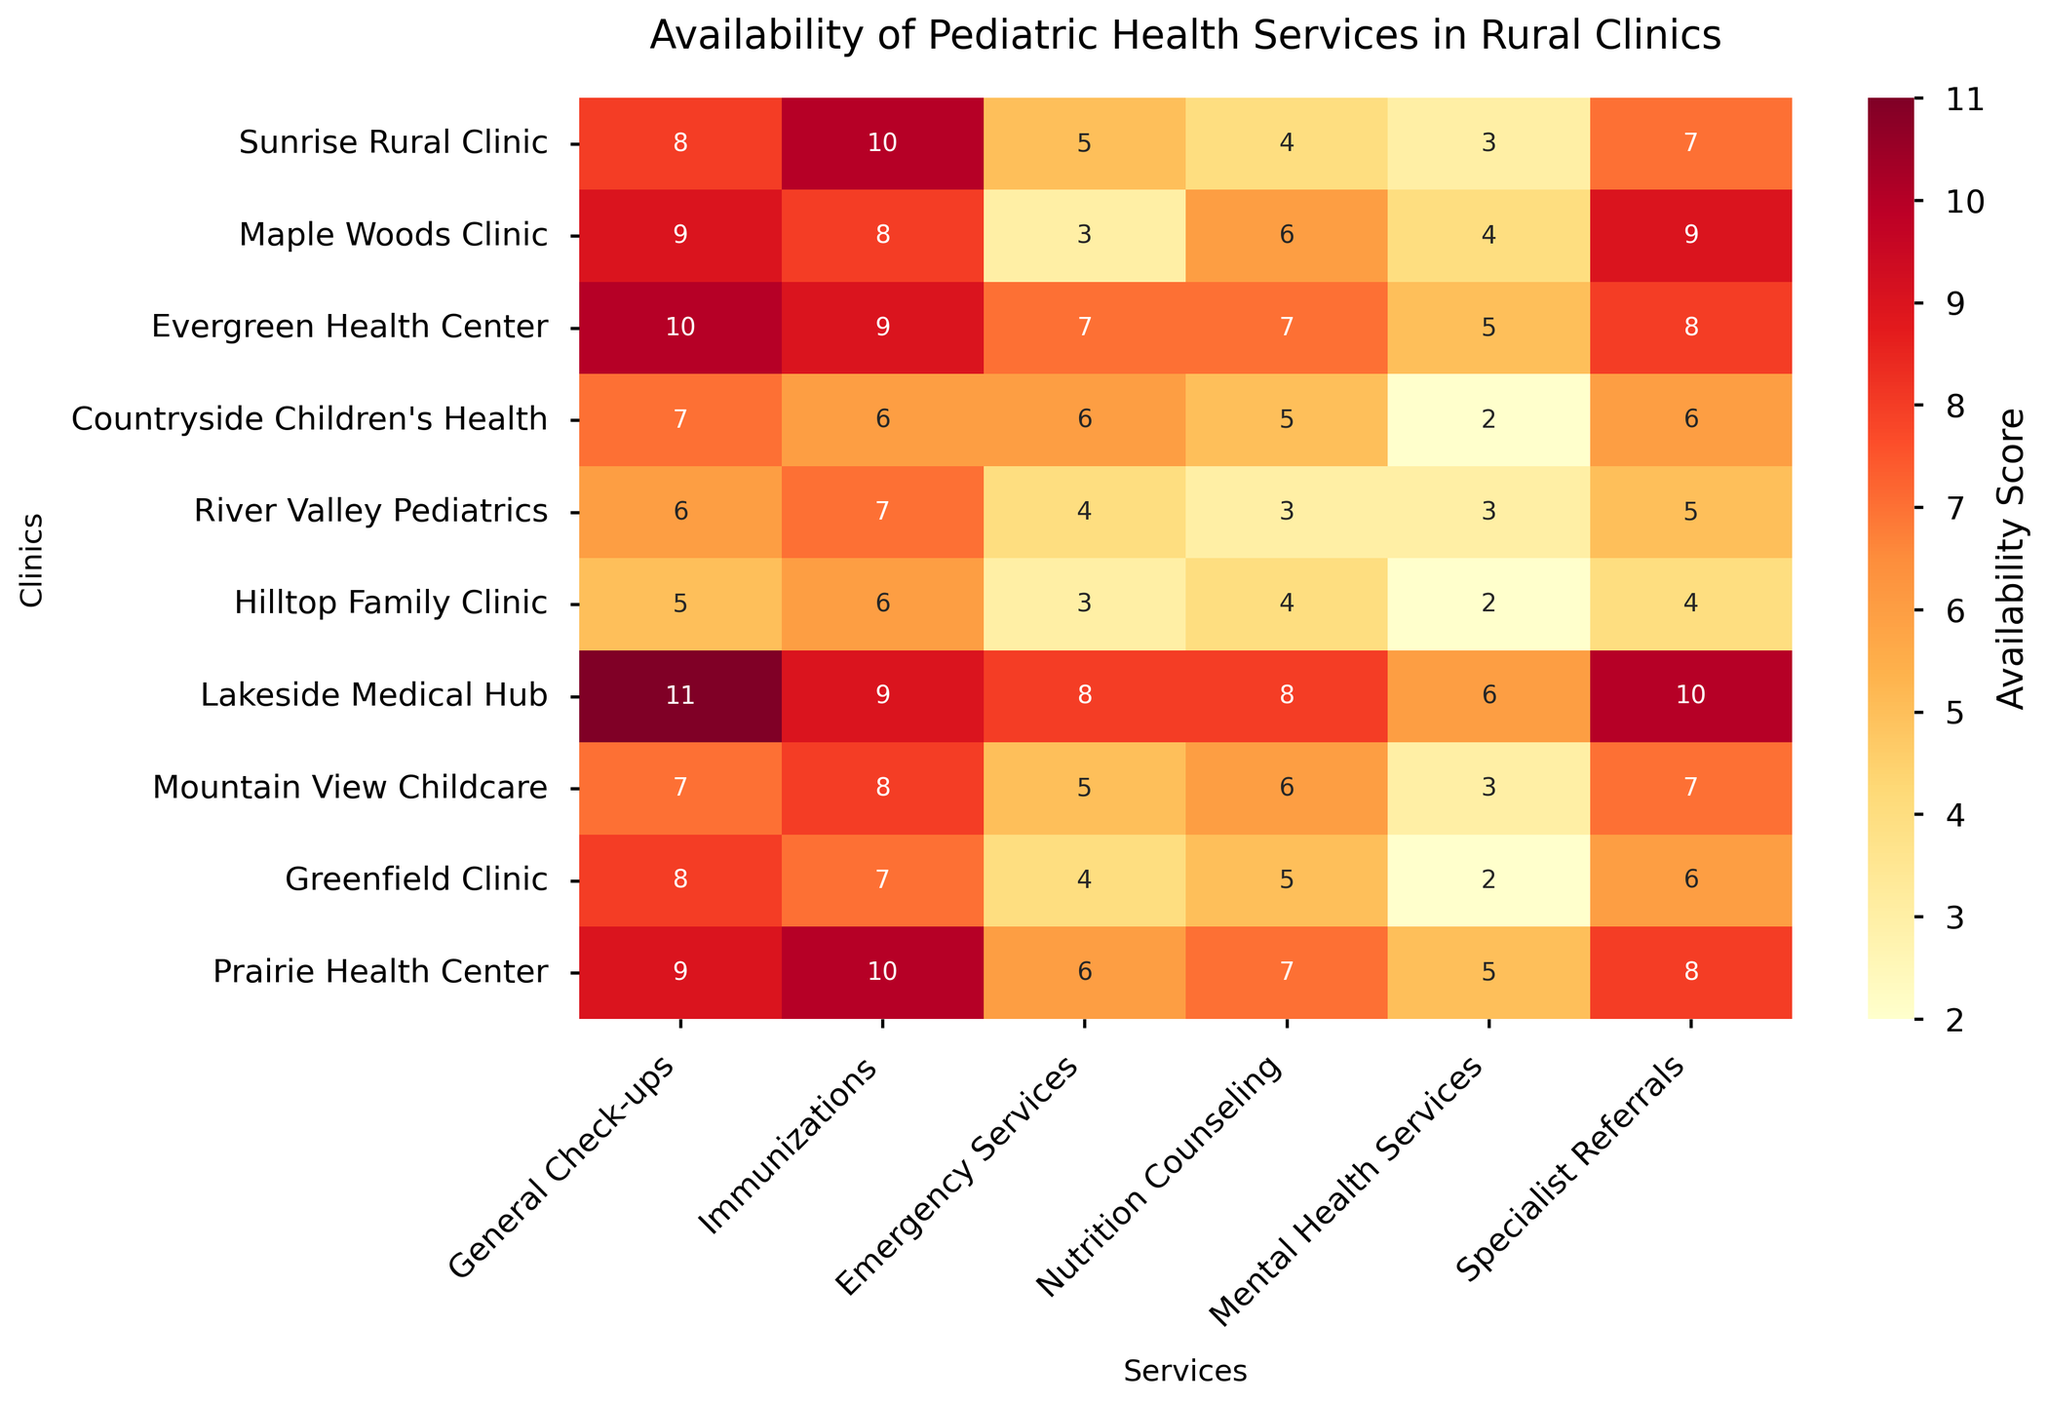Which clinic has the highest availability score for General Check-ups? To determine this, look at the column labeled "General Check-ups" and find the highest number. The highest value is 11, which corresponds to Lakeside Medical Hub.
Answer: Lakeside Medical Hub What is the total availability score for Nutrition Counseling across all clinics? Sum all the values in the "Nutrition Counseling" column: 4 + 6 + 7 + 5 + 3 + 4 + 8 + 6 + 5 + 7 = 55.
Answer: 55 Which clinic has the lowest availability score for Mental Health Services? Look at the "Mental Health Services" column and find the clinic with the smallest number, which is Hilltop Family Clinic with a score of 2.
Answer: Hilltop Family Clinic What is the difference between the availability scores of Nutrition Counseling at Lakeside Medical Hub and River Valley Pediatrics? The values for Nutrition Counseling are 8 for Lakeside Medical Hub and 3 for River Valley Pediatrics. The difference is 8 - 3 = 5.
Answer: 5 How many clinics have an availability score of 7 or higher for Immunizations? Count the clinics in the "Immunizations" column with scores 7 or higher: Sunrise Rural Clinic (10), Evergreen Health Center (9), Lakeside Medical Hub (9), Mountain View Childcare (8), Prairie Health Center (10). That makes 5 clinics.
Answer: 5 Which service has the highest availability score in the figure? Scan through all the columns to find the highest score, which is 11. It belongs to the General Check-ups column for Lakeside Medical Hub.
Answer: General Check-ups Which clinics have availability scores greater than 6 for Specialist Referrals? List the clinics in the "Specialist Referrals" column with scores greater than 6: Sunrise Rural Clinic (7), Maple Woods Clinic (9), Evergreen Health Center (8), Lakeside Medical Hub (10), Prairie Health Center (8).
Answer: Sunrise Rural Clinic, Maple Woods Clinic, Evergreen Health Center, Lakeside Medical Hub, Prairie Health Center What is the average availability score for Emergency Services across all clinics? Calculate the average by summing all the values in the "Emergency Services" column and dividing by the number of clinics: (5 + 3 + 7 + 6 + 4 + 3 + 8 + 5 + 4 + 6) / 10 = 51 / 10 = 5.1.
Answer: 5.1 